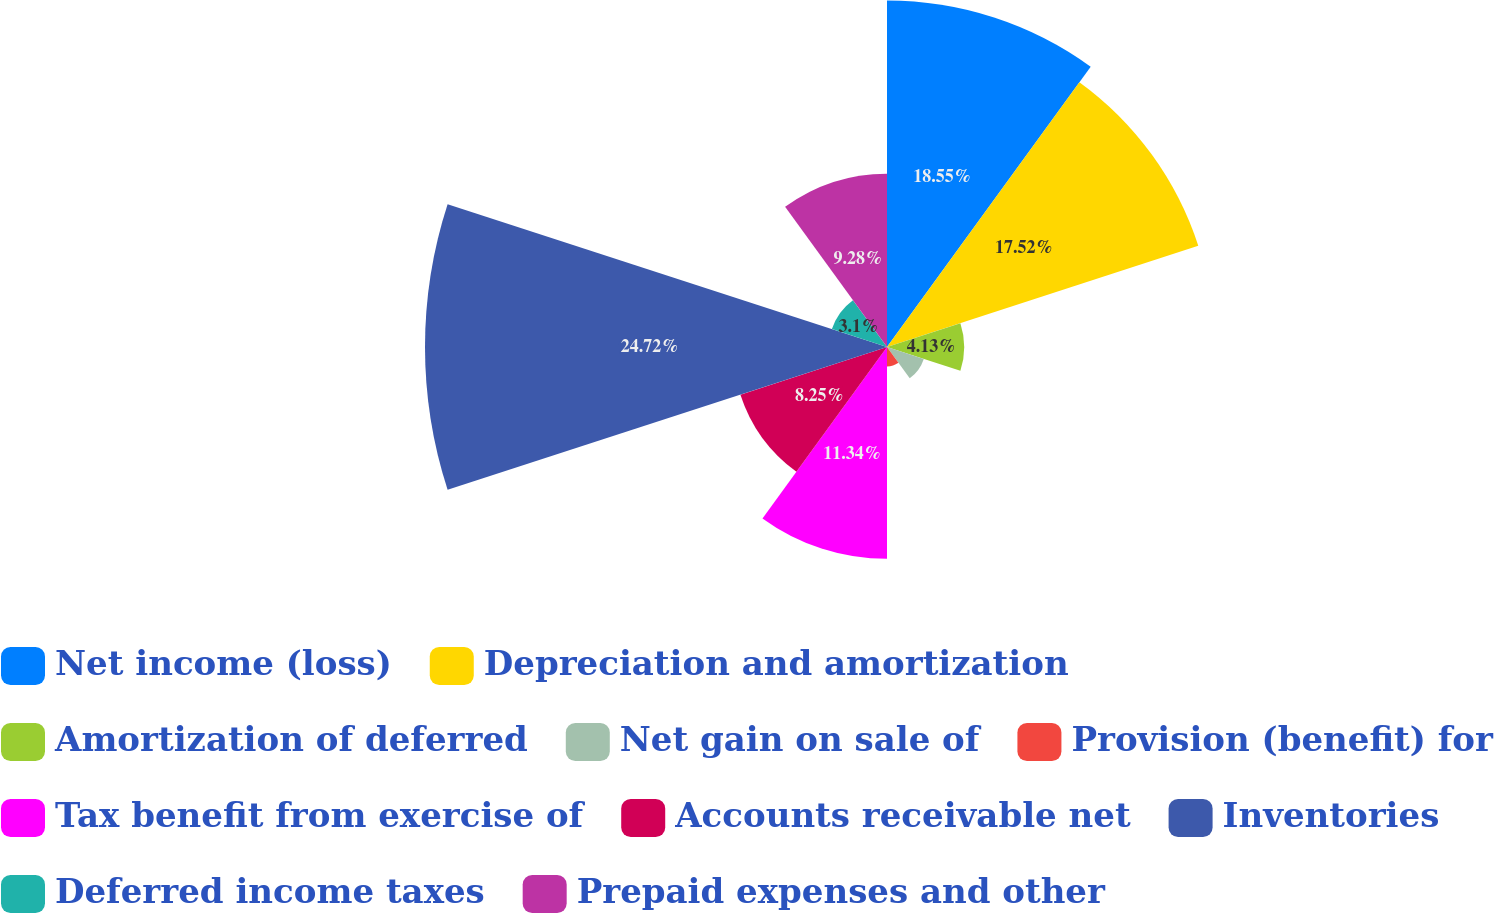<chart> <loc_0><loc_0><loc_500><loc_500><pie_chart><fcel>Net income (loss)<fcel>Depreciation and amortization<fcel>Amortization of deferred<fcel>Net gain on sale of<fcel>Provision (benefit) for<fcel>Tax benefit from exercise of<fcel>Accounts receivable net<fcel>Inventories<fcel>Deferred income taxes<fcel>Prepaid expenses and other<nl><fcel>18.55%<fcel>17.52%<fcel>4.13%<fcel>2.07%<fcel>1.04%<fcel>11.34%<fcel>8.25%<fcel>24.73%<fcel>3.1%<fcel>9.28%<nl></chart> 